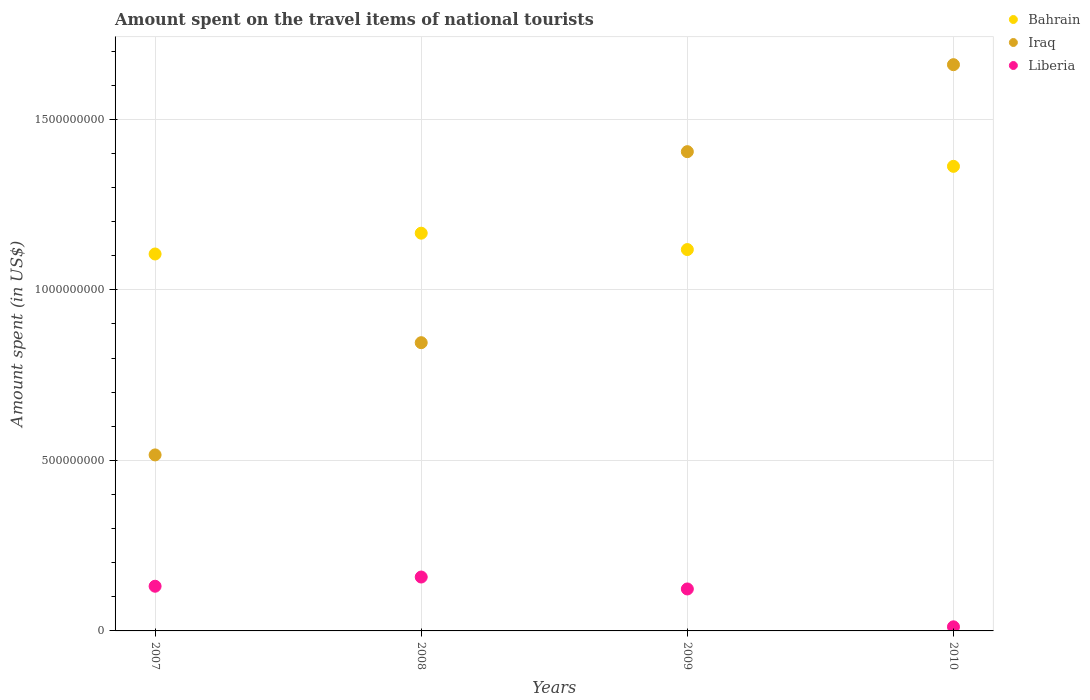Is the number of dotlines equal to the number of legend labels?
Offer a terse response. Yes. What is the amount spent on the travel items of national tourists in Bahrain in 2009?
Give a very brief answer. 1.12e+09. Across all years, what is the maximum amount spent on the travel items of national tourists in Bahrain?
Offer a terse response. 1.36e+09. Across all years, what is the minimum amount spent on the travel items of national tourists in Bahrain?
Offer a terse response. 1.10e+09. What is the total amount spent on the travel items of national tourists in Liberia in the graph?
Make the answer very short. 4.24e+08. What is the difference between the amount spent on the travel items of national tourists in Liberia in 2008 and that in 2010?
Provide a short and direct response. 1.46e+08. What is the difference between the amount spent on the travel items of national tourists in Iraq in 2007 and the amount spent on the travel items of national tourists in Liberia in 2009?
Provide a succinct answer. 3.93e+08. What is the average amount spent on the travel items of national tourists in Bahrain per year?
Your answer should be compact. 1.19e+09. In the year 2007, what is the difference between the amount spent on the travel items of national tourists in Liberia and amount spent on the travel items of national tourists in Bahrain?
Make the answer very short. -9.74e+08. What is the ratio of the amount spent on the travel items of national tourists in Liberia in 2009 to that in 2010?
Make the answer very short. 10.25. Is the difference between the amount spent on the travel items of national tourists in Liberia in 2007 and 2009 greater than the difference between the amount spent on the travel items of national tourists in Bahrain in 2007 and 2009?
Offer a terse response. Yes. What is the difference between the highest and the second highest amount spent on the travel items of national tourists in Liberia?
Offer a terse response. 2.70e+07. What is the difference between the highest and the lowest amount spent on the travel items of national tourists in Bahrain?
Offer a terse response. 2.57e+08. In how many years, is the amount spent on the travel items of national tourists in Bahrain greater than the average amount spent on the travel items of national tourists in Bahrain taken over all years?
Make the answer very short. 1. Does the amount spent on the travel items of national tourists in Bahrain monotonically increase over the years?
Give a very brief answer. No. Is the amount spent on the travel items of national tourists in Liberia strictly greater than the amount spent on the travel items of national tourists in Bahrain over the years?
Your answer should be compact. No. What is the difference between two consecutive major ticks on the Y-axis?
Provide a short and direct response. 5.00e+08. Does the graph contain any zero values?
Give a very brief answer. No. Does the graph contain grids?
Keep it short and to the point. Yes. What is the title of the graph?
Ensure brevity in your answer.  Amount spent on the travel items of national tourists. Does "Least developed countries" appear as one of the legend labels in the graph?
Offer a terse response. No. What is the label or title of the Y-axis?
Your response must be concise. Amount spent (in US$). What is the Amount spent (in US$) in Bahrain in 2007?
Provide a short and direct response. 1.10e+09. What is the Amount spent (in US$) in Iraq in 2007?
Your answer should be very brief. 5.16e+08. What is the Amount spent (in US$) of Liberia in 2007?
Ensure brevity in your answer.  1.31e+08. What is the Amount spent (in US$) in Bahrain in 2008?
Ensure brevity in your answer.  1.17e+09. What is the Amount spent (in US$) of Iraq in 2008?
Make the answer very short. 8.45e+08. What is the Amount spent (in US$) in Liberia in 2008?
Offer a terse response. 1.58e+08. What is the Amount spent (in US$) of Bahrain in 2009?
Provide a short and direct response. 1.12e+09. What is the Amount spent (in US$) of Iraq in 2009?
Provide a short and direct response. 1.40e+09. What is the Amount spent (in US$) of Liberia in 2009?
Offer a very short reply. 1.23e+08. What is the Amount spent (in US$) in Bahrain in 2010?
Provide a short and direct response. 1.36e+09. What is the Amount spent (in US$) of Iraq in 2010?
Your response must be concise. 1.66e+09. What is the Amount spent (in US$) of Liberia in 2010?
Make the answer very short. 1.20e+07. Across all years, what is the maximum Amount spent (in US$) in Bahrain?
Keep it short and to the point. 1.36e+09. Across all years, what is the maximum Amount spent (in US$) of Iraq?
Offer a terse response. 1.66e+09. Across all years, what is the maximum Amount spent (in US$) of Liberia?
Offer a very short reply. 1.58e+08. Across all years, what is the minimum Amount spent (in US$) in Bahrain?
Your response must be concise. 1.10e+09. Across all years, what is the minimum Amount spent (in US$) of Iraq?
Keep it short and to the point. 5.16e+08. What is the total Amount spent (in US$) in Bahrain in the graph?
Give a very brief answer. 4.75e+09. What is the total Amount spent (in US$) in Iraq in the graph?
Make the answer very short. 4.43e+09. What is the total Amount spent (in US$) of Liberia in the graph?
Your response must be concise. 4.24e+08. What is the difference between the Amount spent (in US$) of Bahrain in 2007 and that in 2008?
Give a very brief answer. -6.10e+07. What is the difference between the Amount spent (in US$) of Iraq in 2007 and that in 2008?
Ensure brevity in your answer.  -3.29e+08. What is the difference between the Amount spent (in US$) in Liberia in 2007 and that in 2008?
Provide a succinct answer. -2.70e+07. What is the difference between the Amount spent (in US$) in Bahrain in 2007 and that in 2009?
Offer a very short reply. -1.30e+07. What is the difference between the Amount spent (in US$) in Iraq in 2007 and that in 2009?
Your answer should be very brief. -8.89e+08. What is the difference between the Amount spent (in US$) in Liberia in 2007 and that in 2009?
Provide a succinct answer. 8.00e+06. What is the difference between the Amount spent (in US$) in Bahrain in 2007 and that in 2010?
Ensure brevity in your answer.  -2.57e+08. What is the difference between the Amount spent (in US$) of Iraq in 2007 and that in 2010?
Offer a terse response. -1.14e+09. What is the difference between the Amount spent (in US$) in Liberia in 2007 and that in 2010?
Your answer should be compact. 1.19e+08. What is the difference between the Amount spent (in US$) in Bahrain in 2008 and that in 2009?
Provide a short and direct response. 4.80e+07. What is the difference between the Amount spent (in US$) of Iraq in 2008 and that in 2009?
Offer a terse response. -5.60e+08. What is the difference between the Amount spent (in US$) of Liberia in 2008 and that in 2009?
Keep it short and to the point. 3.50e+07. What is the difference between the Amount spent (in US$) of Bahrain in 2008 and that in 2010?
Your response must be concise. -1.96e+08. What is the difference between the Amount spent (in US$) of Iraq in 2008 and that in 2010?
Your answer should be compact. -8.15e+08. What is the difference between the Amount spent (in US$) of Liberia in 2008 and that in 2010?
Keep it short and to the point. 1.46e+08. What is the difference between the Amount spent (in US$) of Bahrain in 2009 and that in 2010?
Provide a short and direct response. -2.44e+08. What is the difference between the Amount spent (in US$) of Iraq in 2009 and that in 2010?
Offer a terse response. -2.55e+08. What is the difference between the Amount spent (in US$) of Liberia in 2009 and that in 2010?
Provide a succinct answer. 1.11e+08. What is the difference between the Amount spent (in US$) in Bahrain in 2007 and the Amount spent (in US$) in Iraq in 2008?
Provide a short and direct response. 2.60e+08. What is the difference between the Amount spent (in US$) in Bahrain in 2007 and the Amount spent (in US$) in Liberia in 2008?
Your response must be concise. 9.47e+08. What is the difference between the Amount spent (in US$) in Iraq in 2007 and the Amount spent (in US$) in Liberia in 2008?
Offer a terse response. 3.58e+08. What is the difference between the Amount spent (in US$) of Bahrain in 2007 and the Amount spent (in US$) of Iraq in 2009?
Ensure brevity in your answer.  -3.00e+08. What is the difference between the Amount spent (in US$) of Bahrain in 2007 and the Amount spent (in US$) of Liberia in 2009?
Keep it short and to the point. 9.82e+08. What is the difference between the Amount spent (in US$) in Iraq in 2007 and the Amount spent (in US$) in Liberia in 2009?
Offer a very short reply. 3.93e+08. What is the difference between the Amount spent (in US$) in Bahrain in 2007 and the Amount spent (in US$) in Iraq in 2010?
Ensure brevity in your answer.  -5.55e+08. What is the difference between the Amount spent (in US$) of Bahrain in 2007 and the Amount spent (in US$) of Liberia in 2010?
Ensure brevity in your answer.  1.09e+09. What is the difference between the Amount spent (in US$) in Iraq in 2007 and the Amount spent (in US$) in Liberia in 2010?
Give a very brief answer. 5.04e+08. What is the difference between the Amount spent (in US$) in Bahrain in 2008 and the Amount spent (in US$) in Iraq in 2009?
Your answer should be compact. -2.39e+08. What is the difference between the Amount spent (in US$) of Bahrain in 2008 and the Amount spent (in US$) of Liberia in 2009?
Your response must be concise. 1.04e+09. What is the difference between the Amount spent (in US$) of Iraq in 2008 and the Amount spent (in US$) of Liberia in 2009?
Provide a succinct answer. 7.22e+08. What is the difference between the Amount spent (in US$) of Bahrain in 2008 and the Amount spent (in US$) of Iraq in 2010?
Give a very brief answer. -4.94e+08. What is the difference between the Amount spent (in US$) of Bahrain in 2008 and the Amount spent (in US$) of Liberia in 2010?
Your answer should be very brief. 1.15e+09. What is the difference between the Amount spent (in US$) in Iraq in 2008 and the Amount spent (in US$) in Liberia in 2010?
Ensure brevity in your answer.  8.33e+08. What is the difference between the Amount spent (in US$) in Bahrain in 2009 and the Amount spent (in US$) in Iraq in 2010?
Ensure brevity in your answer.  -5.42e+08. What is the difference between the Amount spent (in US$) in Bahrain in 2009 and the Amount spent (in US$) in Liberia in 2010?
Offer a very short reply. 1.11e+09. What is the difference between the Amount spent (in US$) of Iraq in 2009 and the Amount spent (in US$) of Liberia in 2010?
Provide a short and direct response. 1.39e+09. What is the average Amount spent (in US$) of Bahrain per year?
Make the answer very short. 1.19e+09. What is the average Amount spent (in US$) of Iraq per year?
Keep it short and to the point. 1.11e+09. What is the average Amount spent (in US$) in Liberia per year?
Provide a succinct answer. 1.06e+08. In the year 2007, what is the difference between the Amount spent (in US$) of Bahrain and Amount spent (in US$) of Iraq?
Your answer should be compact. 5.89e+08. In the year 2007, what is the difference between the Amount spent (in US$) in Bahrain and Amount spent (in US$) in Liberia?
Your answer should be very brief. 9.74e+08. In the year 2007, what is the difference between the Amount spent (in US$) of Iraq and Amount spent (in US$) of Liberia?
Offer a very short reply. 3.85e+08. In the year 2008, what is the difference between the Amount spent (in US$) in Bahrain and Amount spent (in US$) in Iraq?
Ensure brevity in your answer.  3.21e+08. In the year 2008, what is the difference between the Amount spent (in US$) in Bahrain and Amount spent (in US$) in Liberia?
Provide a short and direct response. 1.01e+09. In the year 2008, what is the difference between the Amount spent (in US$) in Iraq and Amount spent (in US$) in Liberia?
Keep it short and to the point. 6.87e+08. In the year 2009, what is the difference between the Amount spent (in US$) of Bahrain and Amount spent (in US$) of Iraq?
Give a very brief answer. -2.87e+08. In the year 2009, what is the difference between the Amount spent (in US$) in Bahrain and Amount spent (in US$) in Liberia?
Your answer should be compact. 9.95e+08. In the year 2009, what is the difference between the Amount spent (in US$) of Iraq and Amount spent (in US$) of Liberia?
Ensure brevity in your answer.  1.28e+09. In the year 2010, what is the difference between the Amount spent (in US$) in Bahrain and Amount spent (in US$) in Iraq?
Provide a succinct answer. -2.98e+08. In the year 2010, what is the difference between the Amount spent (in US$) in Bahrain and Amount spent (in US$) in Liberia?
Give a very brief answer. 1.35e+09. In the year 2010, what is the difference between the Amount spent (in US$) of Iraq and Amount spent (in US$) of Liberia?
Keep it short and to the point. 1.65e+09. What is the ratio of the Amount spent (in US$) in Bahrain in 2007 to that in 2008?
Ensure brevity in your answer.  0.95. What is the ratio of the Amount spent (in US$) of Iraq in 2007 to that in 2008?
Your response must be concise. 0.61. What is the ratio of the Amount spent (in US$) in Liberia in 2007 to that in 2008?
Offer a terse response. 0.83. What is the ratio of the Amount spent (in US$) of Bahrain in 2007 to that in 2009?
Keep it short and to the point. 0.99. What is the ratio of the Amount spent (in US$) of Iraq in 2007 to that in 2009?
Make the answer very short. 0.37. What is the ratio of the Amount spent (in US$) in Liberia in 2007 to that in 2009?
Provide a short and direct response. 1.06. What is the ratio of the Amount spent (in US$) of Bahrain in 2007 to that in 2010?
Your response must be concise. 0.81. What is the ratio of the Amount spent (in US$) in Iraq in 2007 to that in 2010?
Provide a short and direct response. 0.31. What is the ratio of the Amount spent (in US$) of Liberia in 2007 to that in 2010?
Your answer should be compact. 10.92. What is the ratio of the Amount spent (in US$) of Bahrain in 2008 to that in 2009?
Your answer should be very brief. 1.04. What is the ratio of the Amount spent (in US$) in Iraq in 2008 to that in 2009?
Keep it short and to the point. 0.6. What is the ratio of the Amount spent (in US$) in Liberia in 2008 to that in 2009?
Your answer should be very brief. 1.28. What is the ratio of the Amount spent (in US$) in Bahrain in 2008 to that in 2010?
Provide a succinct answer. 0.86. What is the ratio of the Amount spent (in US$) of Iraq in 2008 to that in 2010?
Ensure brevity in your answer.  0.51. What is the ratio of the Amount spent (in US$) of Liberia in 2008 to that in 2010?
Provide a succinct answer. 13.17. What is the ratio of the Amount spent (in US$) of Bahrain in 2009 to that in 2010?
Your response must be concise. 0.82. What is the ratio of the Amount spent (in US$) of Iraq in 2009 to that in 2010?
Your response must be concise. 0.85. What is the ratio of the Amount spent (in US$) of Liberia in 2009 to that in 2010?
Provide a succinct answer. 10.25. What is the difference between the highest and the second highest Amount spent (in US$) of Bahrain?
Keep it short and to the point. 1.96e+08. What is the difference between the highest and the second highest Amount spent (in US$) in Iraq?
Provide a short and direct response. 2.55e+08. What is the difference between the highest and the second highest Amount spent (in US$) in Liberia?
Your answer should be compact. 2.70e+07. What is the difference between the highest and the lowest Amount spent (in US$) of Bahrain?
Make the answer very short. 2.57e+08. What is the difference between the highest and the lowest Amount spent (in US$) in Iraq?
Offer a terse response. 1.14e+09. What is the difference between the highest and the lowest Amount spent (in US$) in Liberia?
Offer a terse response. 1.46e+08. 